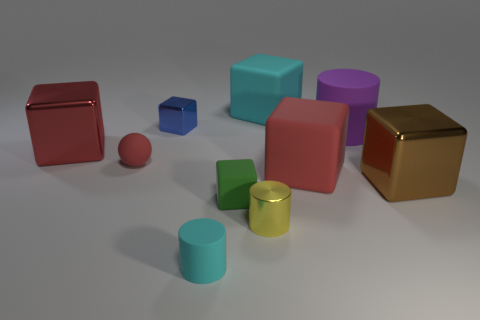Subtract all big metallic cubes. How many cubes are left? 4 Subtract all blue blocks. How many blocks are left? 5 Subtract all cylinders. How many objects are left? 7 Subtract 1 yellow cylinders. How many objects are left? 9 Subtract 1 blocks. How many blocks are left? 5 Subtract all gray cylinders. Subtract all yellow blocks. How many cylinders are left? 3 Subtract all purple cylinders. How many yellow cubes are left? 0 Subtract all green rubber things. Subtract all green matte blocks. How many objects are left? 8 Add 9 small red matte objects. How many small red matte objects are left? 10 Add 9 brown metallic balls. How many brown metallic balls exist? 9 